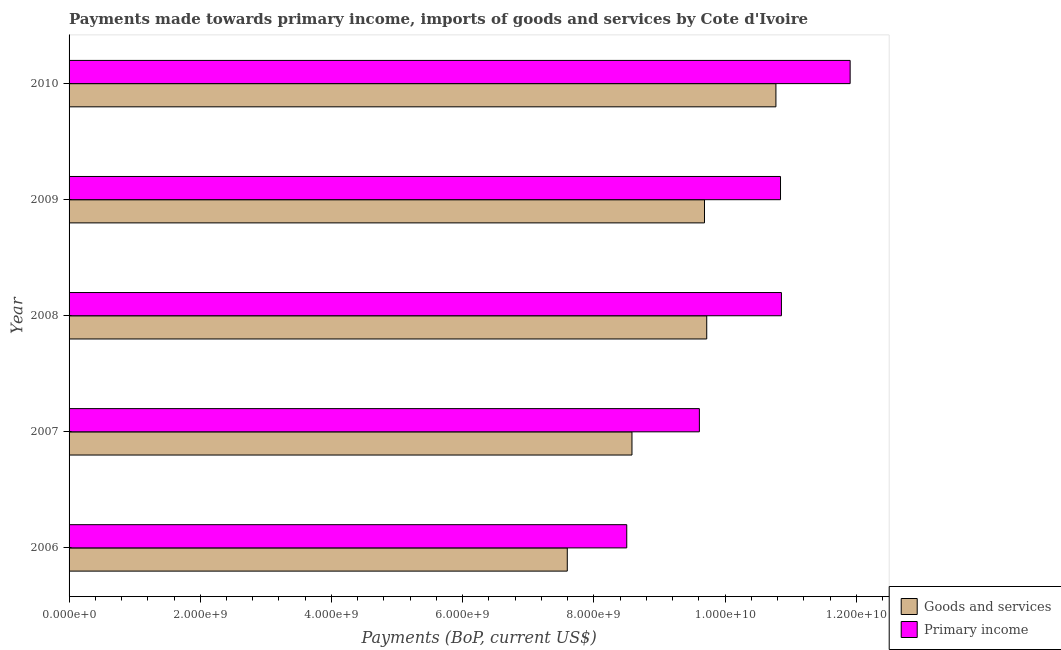How many groups of bars are there?
Offer a very short reply. 5. Are the number of bars per tick equal to the number of legend labels?
Keep it short and to the point. Yes. Are the number of bars on each tick of the Y-axis equal?
Provide a succinct answer. Yes. How many bars are there on the 2nd tick from the bottom?
Give a very brief answer. 2. What is the label of the 2nd group of bars from the top?
Make the answer very short. 2009. What is the payments made towards primary income in 2008?
Keep it short and to the point. 1.09e+1. Across all years, what is the maximum payments made towards primary income?
Your answer should be compact. 1.19e+1. Across all years, what is the minimum payments made towards primary income?
Offer a terse response. 8.50e+09. In which year was the payments made towards goods and services minimum?
Ensure brevity in your answer.  2006. What is the total payments made towards goods and services in the graph?
Your answer should be very brief. 4.64e+1. What is the difference between the payments made towards primary income in 2009 and that in 2010?
Give a very brief answer. -1.06e+09. What is the difference between the payments made towards goods and services in 2009 and the payments made towards primary income in 2008?
Your answer should be very brief. -1.17e+09. What is the average payments made towards primary income per year?
Ensure brevity in your answer.  1.03e+1. In the year 2007, what is the difference between the payments made towards goods and services and payments made towards primary income?
Provide a short and direct response. -1.03e+09. In how many years, is the payments made towards primary income greater than 800000000 US$?
Provide a short and direct response. 5. What is the ratio of the payments made towards goods and services in 2009 to that in 2010?
Your response must be concise. 0.9. Is the payments made towards primary income in 2006 less than that in 2009?
Make the answer very short. Yes. Is the difference between the payments made towards primary income in 2006 and 2007 greater than the difference between the payments made towards goods and services in 2006 and 2007?
Your answer should be compact. No. What is the difference between the highest and the second highest payments made towards primary income?
Give a very brief answer. 1.05e+09. What is the difference between the highest and the lowest payments made towards primary income?
Give a very brief answer. 3.41e+09. Is the sum of the payments made towards goods and services in 2007 and 2008 greater than the maximum payments made towards primary income across all years?
Provide a succinct answer. Yes. What does the 1st bar from the top in 2009 represents?
Ensure brevity in your answer.  Primary income. What does the 1st bar from the bottom in 2009 represents?
Offer a terse response. Goods and services. Are all the bars in the graph horizontal?
Give a very brief answer. Yes. Does the graph contain any zero values?
Make the answer very short. No. Where does the legend appear in the graph?
Provide a short and direct response. Bottom right. How are the legend labels stacked?
Provide a short and direct response. Vertical. What is the title of the graph?
Offer a terse response. Payments made towards primary income, imports of goods and services by Cote d'Ivoire. Does "Investments" appear as one of the legend labels in the graph?
Your response must be concise. No. What is the label or title of the X-axis?
Provide a short and direct response. Payments (BoP, current US$). What is the label or title of the Y-axis?
Your answer should be very brief. Year. What is the Payments (BoP, current US$) in Goods and services in 2006?
Ensure brevity in your answer.  7.59e+09. What is the Payments (BoP, current US$) of Primary income in 2006?
Keep it short and to the point. 8.50e+09. What is the Payments (BoP, current US$) of Goods and services in 2007?
Provide a short and direct response. 8.58e+09. What is the Payments (BoP, current US$) of Primary income in 2007?
Give a very brief answer. 9.61e+09. What is the Payments (BoP, current US$) in Goods and services in 2008?
Ensure brevity in your answer.  9.72e+09. What is the Payments (BoP, current US$) in Primary income in 2008?
Your answer should be compact. 1.09e+1. What is the Payments (BoP, current US$) of Goods and services in 2009?
Your answer should be very brief. 9.69e+09. What is the Payments (BoP, current US$) of Primary income in 2009?
Your answer should be compact. 1.08e+1. What is the Payments (BoP, current US$) of Goods and services in 2010?
Provide a succinct answer. 1.08e+1. What is the Payments (BoP, current US$) in Primary income in 2010?
Ensure brevity in your answer.  1.19e+1. Across all years, what is the maximum Payments (BoP, current US$) in Goods and services?
Provide a succinct answer. 1.08e+1. Across all years, what is the maximum Payments (BoP, current US$) in Primary income?
Your response must be concise. 1.19e+1. Across all years, what is the minimum Payments (BoP, current US$) of Goods and services?
Make the answer very short. 7.59e+09. Across all years, what is the minimum Payments (BoP, current US$) of Primary income?
Ensure brevity in your answer.  8.50e+09. What is the total Payments (BoP, current US$) of Goods and services in the graph?
Provide a succinct answer. 4.64e+1. What is the total Payments (BoP, current US$) in Primary income in the graph?
Give a very brief answer. 5.17e+1. What is the difference between the Payments (BoP, current US$) of Goods and services in 2006 and that in 2007?
Provide a succinct answer. -9.86e+08. What is the difference between the Payments (BoP, current US$) of Primary income in 2006 and that in 2007?
Your response must be concise. -1.11e+09. What is the difference between the Payments (BoP, current US$) of Goods and services in 2006 and that in 2008?
Your answer should be compact. -2.13e+09. What is the difference between the Payments (BoP, current US$) of Primary income in 2006 and that in 2008?
Provide a succinct answer. -2.36e+09. What is the difference between the Payments (BoP, current US$) of Goods and services in 2006 and that in 2009?
Provide a succinct answer. -2.09e+09. What is the difference between the Payments (BoP, current US$) of Primary income in 2006 and that in 2009?
Make the answer very short. -2.34e+09. What is the difference between the Payments (BoP, current US$) in Goods and services in 2006 and that in 2010?
Offer a terse response. -3.18e+09. What is the difference between the Payments (BoP, current US$) in Primary income in 2006 and that in 2010?
Offer a very short reply. -3.41e+09. What is the difference between the Payments (BoP, current US$) in Goods and services in 2007 and that in 2008?
Offer a very short reply. -1.14e+09. What is the difference between the Payments (BoP, current US$) in Primary income in 2007 and that in 2008?
Offer a very short reply. -1.25e+09. What is the difference between the Payments (BoP, current US$) in Goods and services in 2007 and that in 2009?
Ensure brevity in your answer.  -1.11e+09. What is the difference between the Payments (BoP, current US$) of Primary income in 2007 and that in 2009?
Keep it short and to the point. -1.24e+09. What is the difference between the Payments (BoP, current US$) in Goods and services in 2007 and that in 2010?
Make the answer very short. -2.19e+09. What is the difference between the Payments (BoP, current US$) in Primary income in 2007 and that in 2010?
Offer a terse response. -2.30e+09. What is the difference between the Payments (BoP, current US$) in Goods and services in 2008 and that in 2009?
Give a very brief answer. 3.43e+07. What is the difference between the Payments (BoP, current US$) of Primary income in 2008 and that in 2009?
Make the answer very short. 1.39e+07. What is the difference between the Payments (BoP, current US$) of Goods and services in 2008 and that in 2010?
Your answer should be very brief. -1.05e+09. What is the difference between the Payments (BoP, current US$) in Primary income in 2008 and that in 2010?
Provide a short and direct response. -1.05e+09. What is the difference between the Payments (BoP, current US$) of Goods and services in 2009 and that in 2010?
Make the answer very short. -1.09e+09. What is the difference between the Payments (BoP, current US$) of Primary income in 2009 and that in 2010?
Your response must be concise. -1.06e+09. What is the difference between the Payments (BoP, current US$) of Goods and services in 2006 and the Payments (BoP, current US$) of Primary income in 2007?
Keep it short and to the point. -2.01e+09. What is the difference between the Payments (BoP, current US$) in Goods and services in 2006 and the Payments (BoP, current US$) in Primary income in 2008?
Keep it short and to the point. -3.26e+09. What is the difference between the Payments (BoP, current US$) of Goods and services in 2006 and the Payments (BoP, current US$) of Primary income in 2009?
Ensure brevity in your answer.  -3.25e+09. What is the difference between the Payments (BoP, current US$) of Goods and services in 2006 and the Payments (BoP, current US$) of Primary income in 2010?
Provide a succinct answer. -4.31e+09. What is the difference between the Payments (BoP, current US$) of Goods and services in 2007 and the Payments (BoP, current US$) of Primary income in 2008?
Your response must be concise. -2.28e+09. What is the difference between the Payments (BoP, current US$) in Goods and services in 2007 and the Payments (BoP, current US$) in Primary income in 2009?
Provide a succinct answer. -2.26e+09. What is the difference between the Payments (BoP, current US$) of Goods and services in 2007 and the Payments (BoP, current US$) of Primary income in 2010?
Provide a short and direct response. -3.33e+09. What is the difference between the Payments (BoP, current US$) of Goods and services in 2008 and the Payments (BoP, current US$) of Primary income in 2009?
Provide a succinct answer. -1.12e+09. What is the difference between the Payments (BoP, current US$) in Goods and services in 2008 and the Payments (BoP, current US$) in Primary income in 2010?
Offer a very short reply. -2.19e+09. What is the difference between the Payments (BoP, current US$) of Goods and services in 2009 and the Payments (BoP, current US$) of Primary income in 2010?
Offer a terse response. -2.22e+09. What is the average Payments (BoP, current US$) in Goods and services per year?
Your response must be concise. 9.27e+09. What is the average Payments (BoP, current US$) of Primary income per year?
Give a very brief answer. 1.03e+1. In the year 2006, what is the difference between the Payments (BoP, current US$) in Goods and services and Payments (BoP, current US$) in Primary income?
Give a very brief answer. -9.06e+08. In the year 2007, what is the difference between the Payments (BoP, current US$) in Goods and services and Payments (BoP, current US$) in Primary income?
Give a very brief answer. -1.03e+09. In the year 2008, what is the difference between the Payments (BoP, current US$) in Goods and services and Payments (BoP, current US$) in Primary income?
Keep it short and to the point. -1.14e+09. In the year 2009, what is the difference between the Payments (BoP, current US$) in Goods and services and Payments (BoP, current US$) in Primary income?
Offer a very short reply. -1.16e+09. In the year 2010, what is the difference between the Payments (BoP, current US$) in Goods and services and Payments (BoP, current US$) in Primary income?
Ensure brevity in your answer.  -1.13e+09. What is the ratio of the Payments (BoP, current US$) of Goods and services in 2006 to that in 2007?
Keep it short and to the point. 0.89. What is the ratio of the Payments (BoP, current US$) of Primary income in 2006 to that in 2007?
Provide a short and direct response. 0.88. What is the ratio of the Payments (BoP, current US$) of Goods and services in 2006 to that in 2008?
Your answer should be compact. 0.78. What is the ratio of the Payments (BoP, current US$) of Primary income in 2006 to that in 2008?
Offer a very short reply. 0.78. What is the ratio of the Payments (BoP, current US$) in Goods and services in 2006 to that in 2009?
Make the answer very short. 0.78. What is the ratio of the Payments (BoP, current US$) of Primary income in 2006 to that in 2009?
Your answer should be very brief. 0.78. What is the ratio of the Payments (BoP, current US$) in Goods and services in 2006 to that in 2010?
Keep it short and to the point. 0.7. What is the ratio of the Payments (BoP, current US$) of Primary income in 2006 to that in 2010?
Your answer should be compact. 0.71. What is the ratio of the Payments (BoP, current US$) of Goods and services in 2007 to that in 2008?
Your response must be concise. 0.88. What is the ratio of the Payments (BoP, current US$) in Primary income in 2007 to that in 2008?
Offer a very short reply. 0.88. What is the ratio of the Payments (BoP, current US$) of Goods and services in 2007 to that in 2009?
Provide a succinct answer. 0.89. What is the ratio of the Payments (BoP, current US$) in Primary income in 2007 to that in 2009?
Provide a short and direct response. 0.89. What is the ratio of the Payments (BoP, current US$) in Goods and services in 2007 to that in 2010?
Your answer should be compact. 0.8. What is the ratio of the Payments (BoP, current US$) of Primary income in 2007 to that in 2010?
Make the answer very short. 0.81. What is the ratio of the Payments (BoP, current US$) of Goods and services in 2008 to that in 2009?
Keep it short and to the point. 1. What is the ratio of the Payments (BoP, current US$) in Goods and services in 2008 to that in 2010?
Make the answer very short. 0.9. What is the ratio of the Payments (BoP, current US$) of Primary income in 2008 to that in 2010?
Provide a succinct answer. 0.91. What is the ratio of the Payments (BoP, current US$) of Goods and services in 2009 to that in 2010?
Keep it short and to the point. 0.9. What is the ratio of the Payments (BoP, current US$) in Primary income in 2009 to that in 2010?
Offer a very short reply. 0.91. What is the difference between the highest and the second highest Payments (BoP, current US$) in Goods and services?
Offer a very short reply. 1.05e+09. What is the difference between the highest and the second highest Payments (BoP, current US$) in Primary income?
Keep it short and to the point. 1.05e+09. What is the difference between the highest and the lowest Payments (BoP, current US$) in Goods and services?
Make the answer very short. 3.18e+09. What is the difference between the highest and the lowest Payments (BoP, current US$) in Primary income?
Provide a succinct answer. 3.41e+09. 